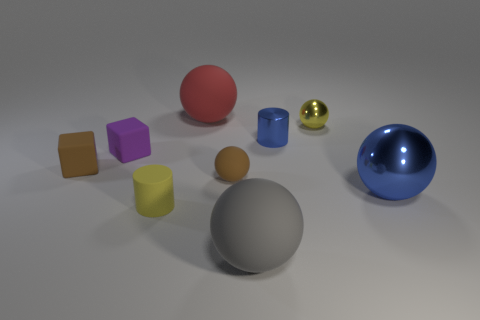Does the small yellow thing right of the red sphere have the same shape as the small blue object?
Offer a terse response. No. What material is the object that is to the left of the purple rubber cube?
Give a very brief answer. Rubber. What shape is the object that is the same color as the large shiny ball?
Your answer should be very brief. Cylinder. Is there a purple ball that has the same material as the blue sphere?
Your response must be concise. No. What is the size of the red thing?
Make the answer very short. Large. How many yellow things are objects or big rubber things?
Your response must be concise. 2. How many small yellow matte objects are the same shape as the tiny blue metallic object?
Provide a short and direct response. 1. What number of yellow matte cylinders have the same size as the brown rubber sphere?
Offer a very short reply. 1. There is a brown thing that is the same shape as the gray matte thing; what is it made of?
Your response must be concise. Rubber. What is the color of the large matte thing that is behind the big metallic sphere?
Provide a succinct answer. Red. 